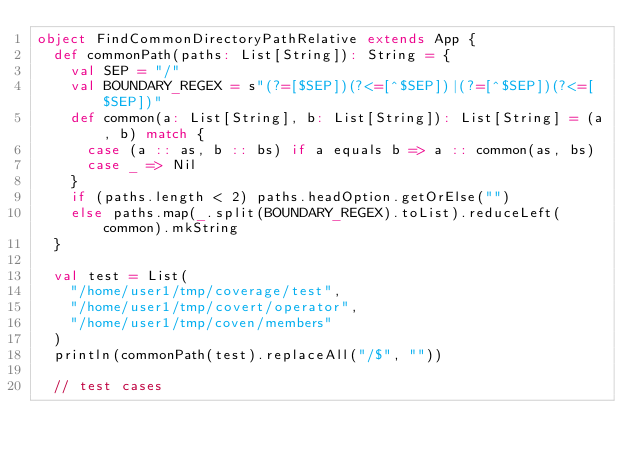<code> <loc_0><loc_0><loc_500><loc_500><_Scala_>object FindCommonDirectoryPathRelative extends App {
  def commonPath(paths: List[String]): String = {
    val SEP = "/"
    val BOUNDARY_REGEX = s"(?=[$SEP])(?<=[^$SEP])|(?=[^$SEP])(?<=[$SEP])"
    def common(a: List[String], b: List[String]): List[String] = (a, b) match {
      case (a :: as, b :: bs) if a equals b => a :: common(as, bs)
      case _ => Nil
    }
    if (paths.length < 2) paths.headOption.getOrElse("")
    else paths.map(_.split(BOUNDARY_REGEX).toList).reduceLeft(common).mkString
  }

  val test = List(
    "/home/user1/tmp/coverage/test",
    "/home/user1/tmp/covert/operator",
    "/home/user1/tmp/coven/members"
  )
  println(commonPath(test).replaceAll("/$", ""))

  // test cases</code> 